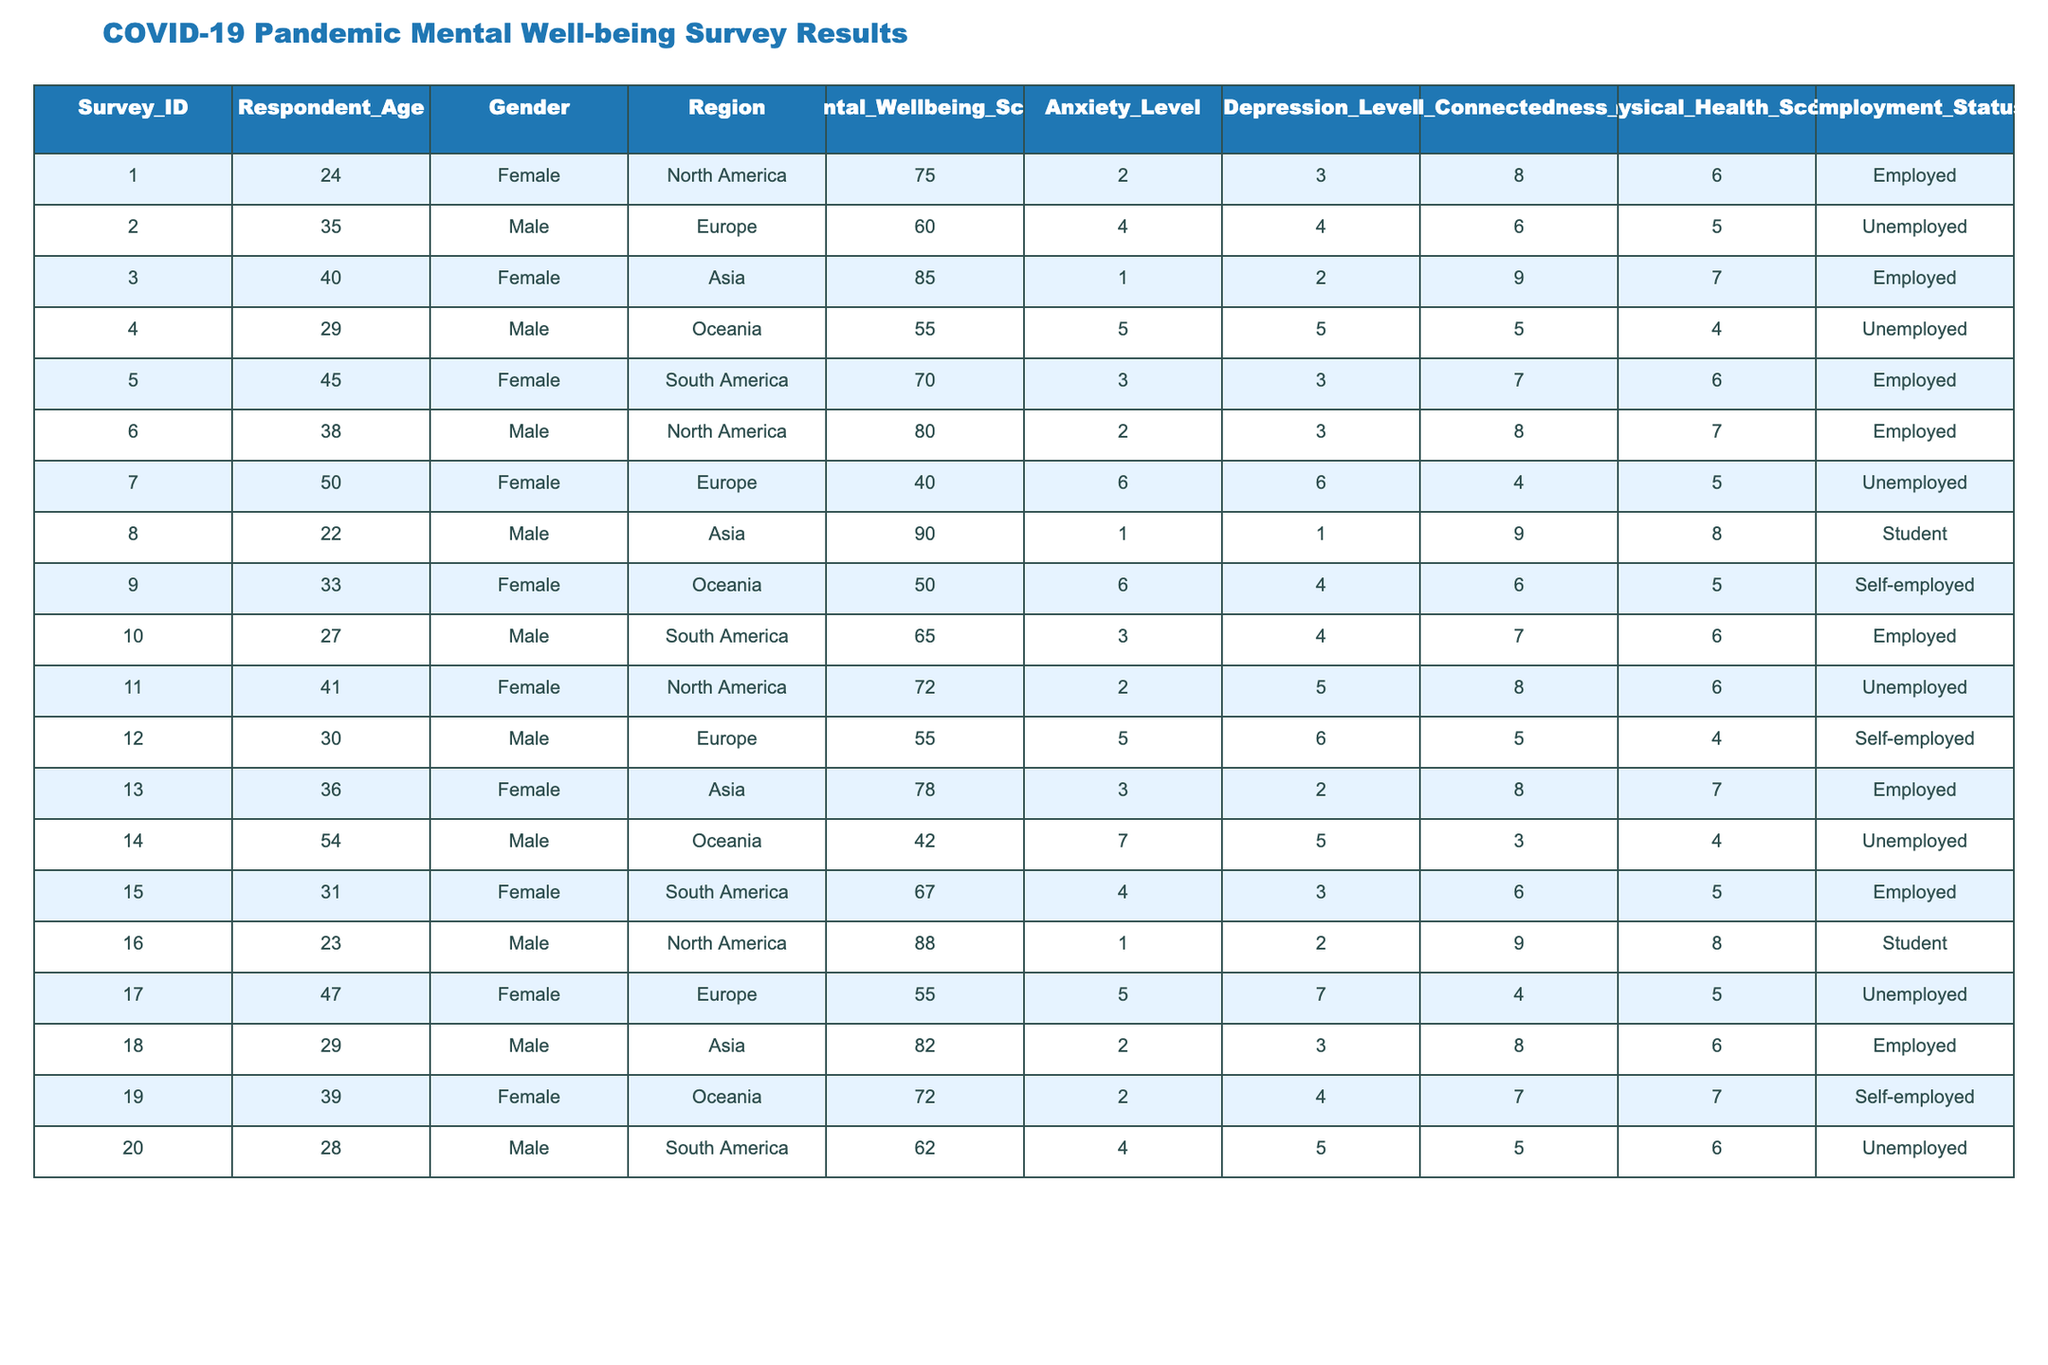What is the mental well-being score of the youngest respondent? The youngest respondent is 22 years old, which corresponds to Survey ID 8, where the Mental Wellbeing Score is 90.
Answer: 90 What is the employment status of the respondent with the highest anxiety level? The respondent with the highest anxiety level is from Survey ID 14, who is Unemployed.
Answer: Unemployed What is the average mental well-being score of female respondents? There are 10 female respondents with scores of 75, 85, 70, 72, 78, 67, 55, 60, 82, and 50. Summing them gives 755. Dividing by 10 results in an average score of 75.5.
Answer: 75.5 How many respondents have a Mental Wellbeing Score above 80? Looking through the data, the respondents with scores above 80 are from Survey IDs 3, 6, and 8, totaling 3 respondents.
Answer: 3 Is there any respondent from South America with a depression level of 6 or higher? Looking at respondents from South America, Survey ID 2 and Survey ID 20 have depression levels of 4 and 5, respectively. None have a depression level of 6 or higher.
Answer: No What is the total mental well-being score of unemployed respondents? The unemployed respondents are from Survey IDs 2, 4, 7, 11, 12, 14, 17, and 20, with scores of 60, 55, 40, 72, 55, 42, 55, and 62 respectively, summing to 408.
Answer: 408 What percentage of respondents have a physical health score greater than or equal to 7? There are 20 respondents in total. Those with scores of 7 or higher are from Survey IDs 3, 6, 13, and 19, totaling 4 respondents, which is 20% of 20.
Answer: 20% Are there any male respondents with a mental wellbeing score below 60? Checking the male respondents, IDs 2, 4, 7, and 14 have scores below 60. Thus, there are male respondents with scores below 60.
Answer: Yes Which region has the highest average anxiety level? The average anxiety levels by region are North America (2), Europe (5), Asia (2.5), Oceania (5.5), South America (4), thus Oceania has the highest average of 5.5.
Answer: Oceania How does the social connectedness score of employed respondents compare to unemployed respondents? The total social connectedness scores for employed respondents (8, 9, 6, 8, 8, 7, 6) average to 7.14, while for unemployed (6, 5, 4, 4, 3, 4, 4) averages to 4.57. Employed individuals score significantly higher.
Answer: Employed score higher 